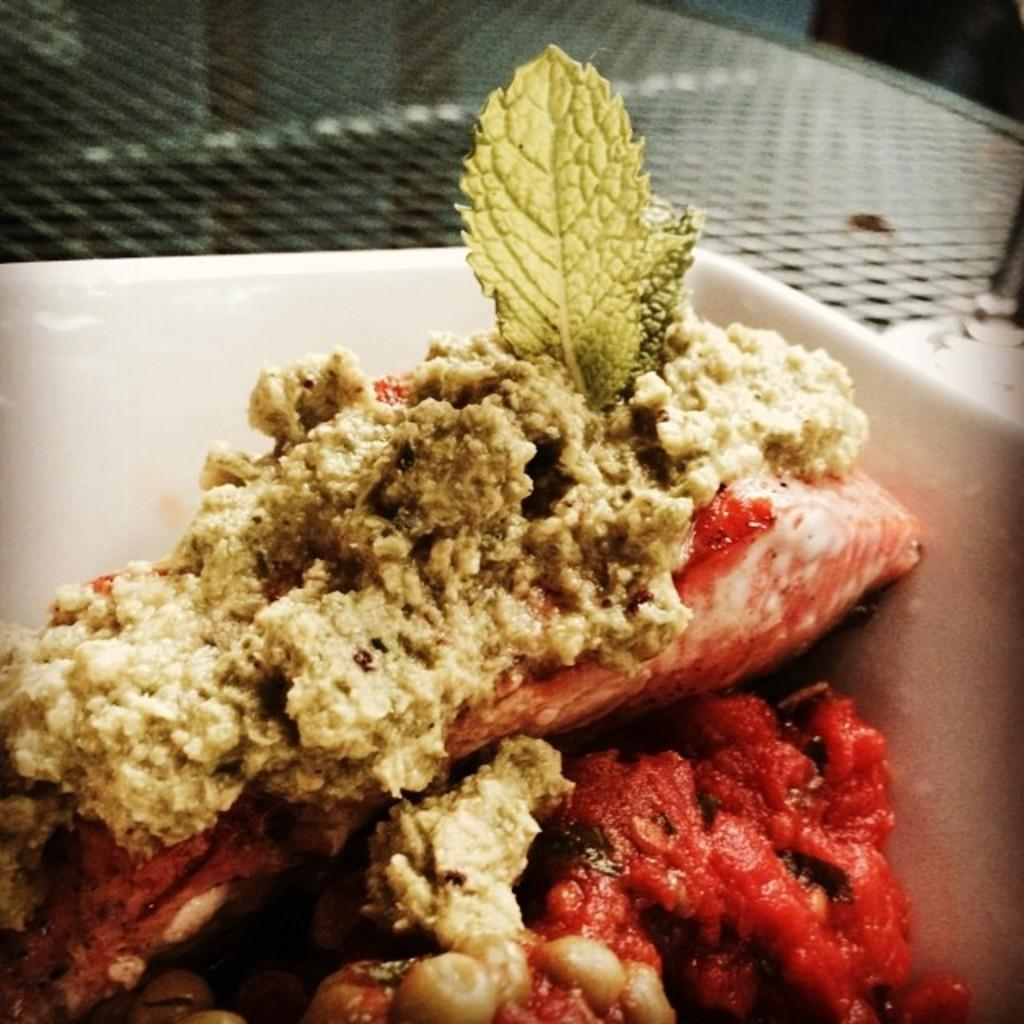What color is the plate that is visible in the image? There is a white color plate in the image. What is on the plate in the image? There are different types of food on the plate. What type of coast can be seen in the image? There is no coast present in the image; it features a plate with different types of food. 